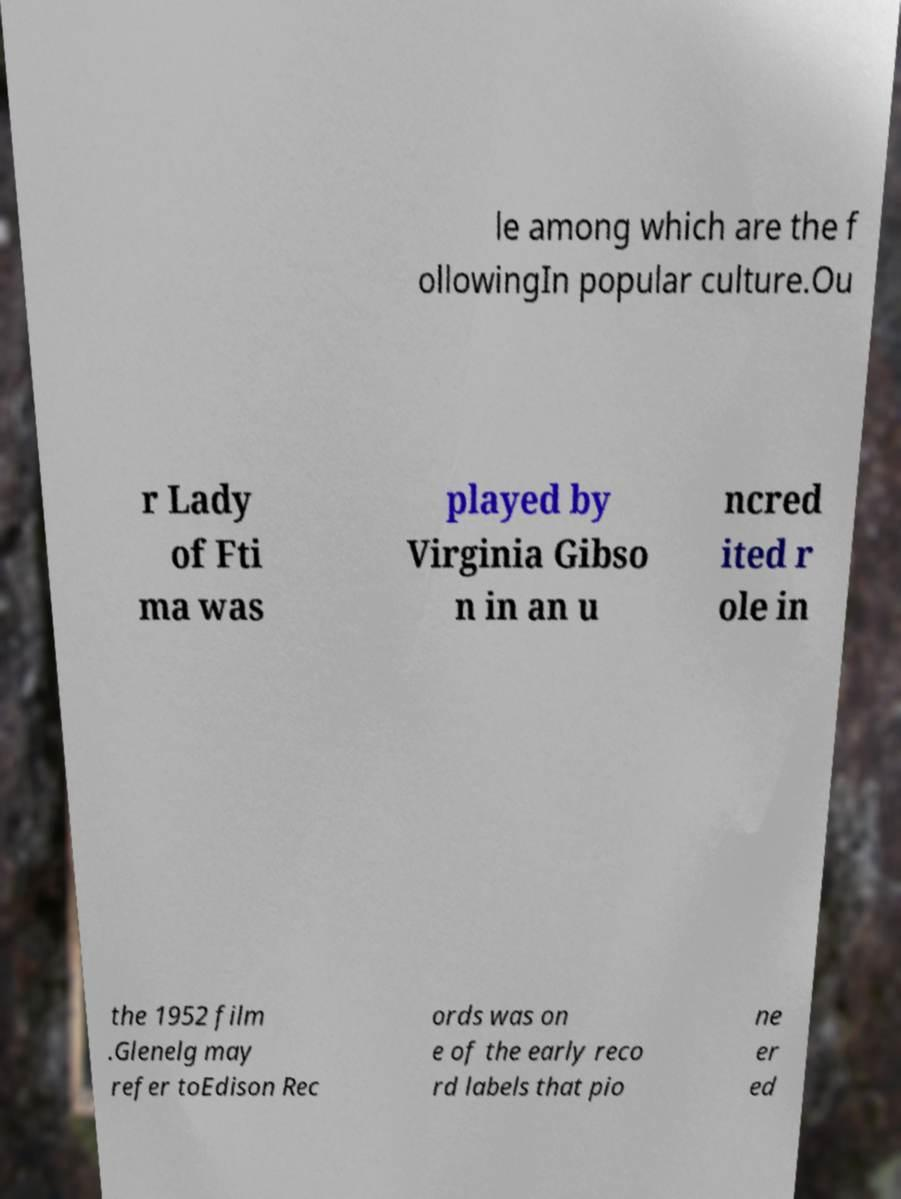For documentation purposes, I need the text within this image transcribed. Could you provide that? le among which are the f ollowingIn popular culture.Ou r Lady of Fti ma was played by Virginia Gibso n in an u ncred ited r ole in the 1952 film .Glenelg may refer toEdison Rec ords was on e of the early reco rd labels that pio ne er ed 